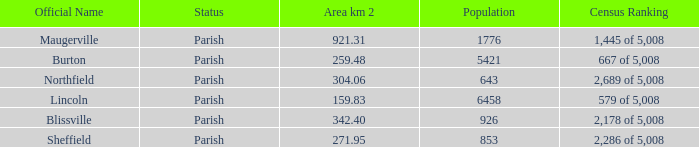What are the census ranking(s) of maugerville? 1,445 of 5,008. 